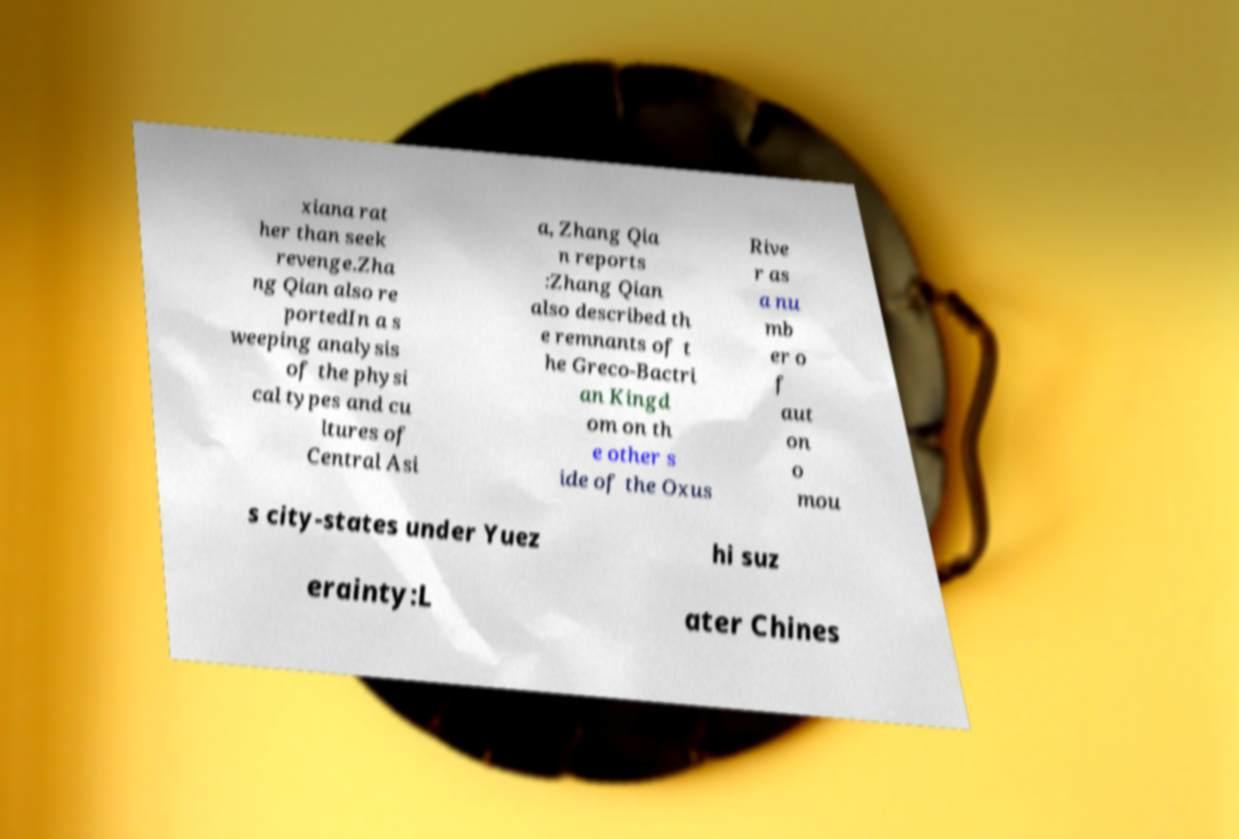I need the written content from this picture converted into text. Can you do that? xiana rat her than seek revenge.Zha ng Qian also re portedIn a s weeping analysis of the physi cal types and cu ltures of Central Asi a, Zhang Qia n reports :Zhang Qian also described th e remnants of t he Greco-Bactri an Kingd om on th e other s ide of the Oxus Rive r as a nu mb er o f aut on o mou s city-states under Yuez hi suz erainty:L ater Chines 